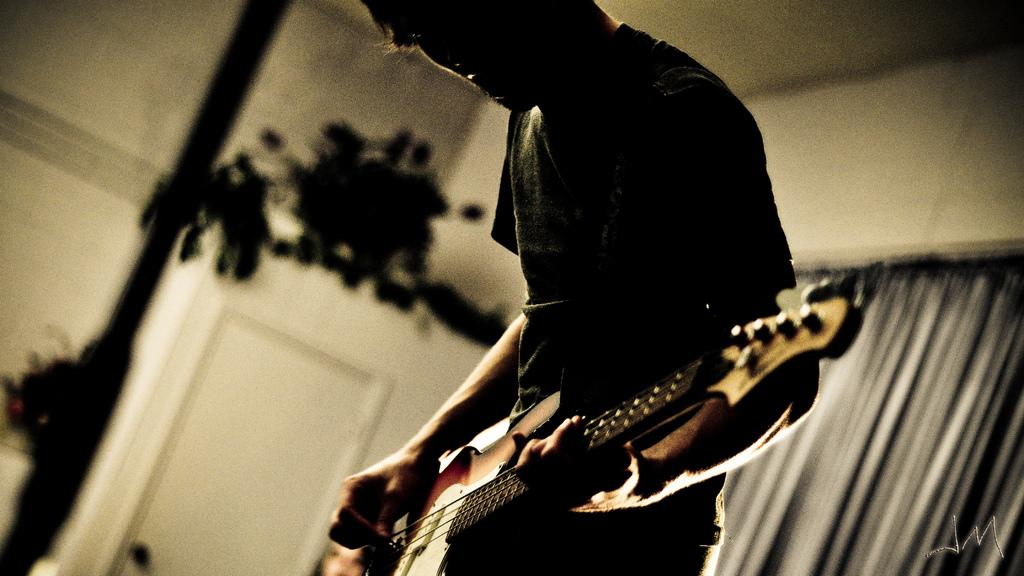What is the main subject of the image? The main subject of the image is a man. What is the man doing in the image? The man is standing and playing a guitar. What type of joke is the squirrel telling in the image? There is no squirrel present in the image, and therefore no such activity can be observed. 